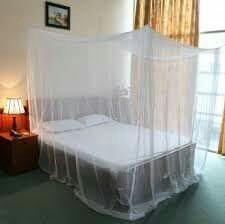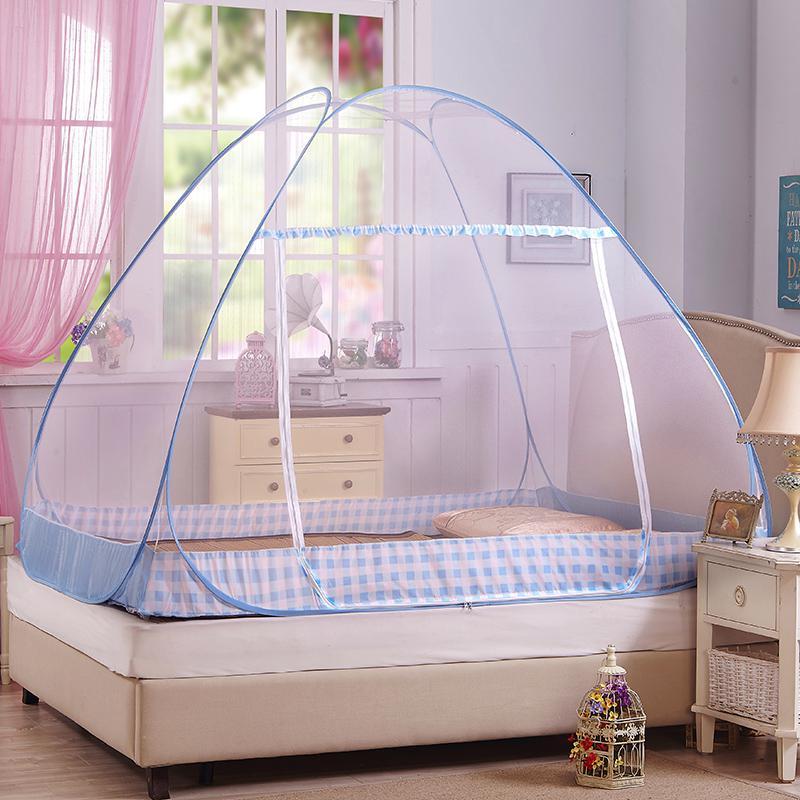The first image is the image on the left, the second image is the image on the right. Examine the images to the left and right. Is the description "There is a stuffed animal on top of one of the beds." accurate? Answer yes or no. No. The first image is the image on the left, the second image is the image on the right. Considering the images on both sides, is "There is a stuffed toy resting on one of the beds." valid? Answer yes or no. No. 